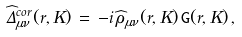<formula> <loc_0><loc_0><loc_500><loc_500>\widehat { \Delta } ^ { c o r } _ { \mu \nu } ( r , K ) \, = \, - i \, \widehat { \rho } _ { \mu \nu } ( r , K ) \, { \tt G } ( r , K ) \, ,</formula> 